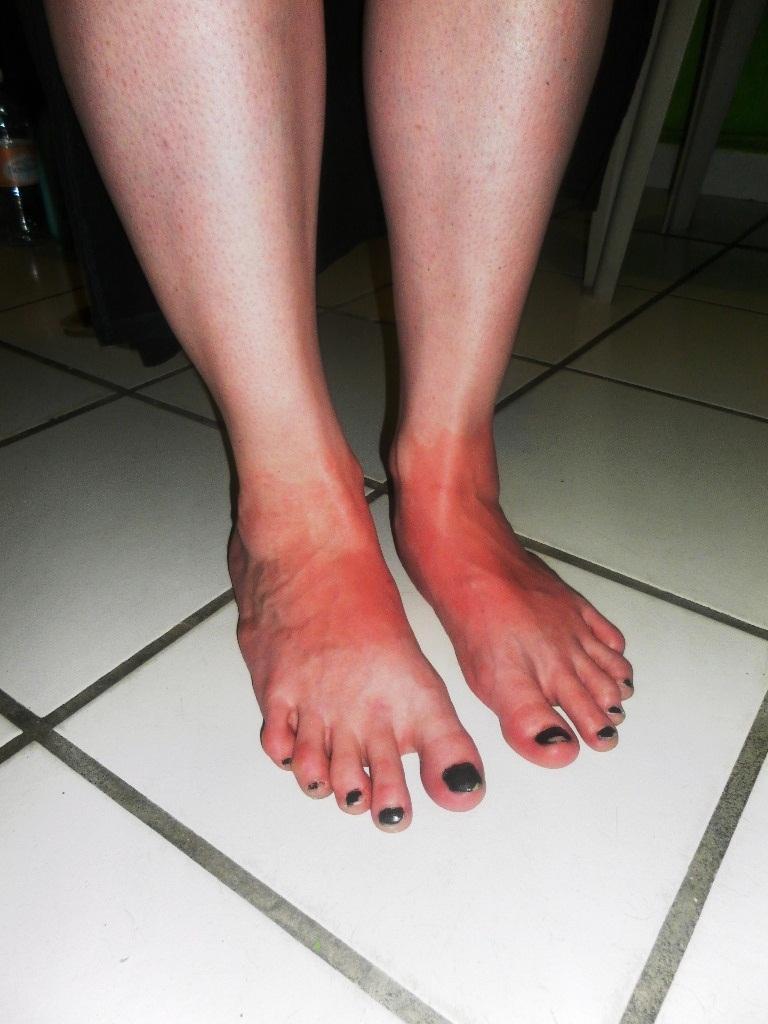How would you summarize this image in a sentence or two? In this image we can see the person's legs, there are some objects in the background. 